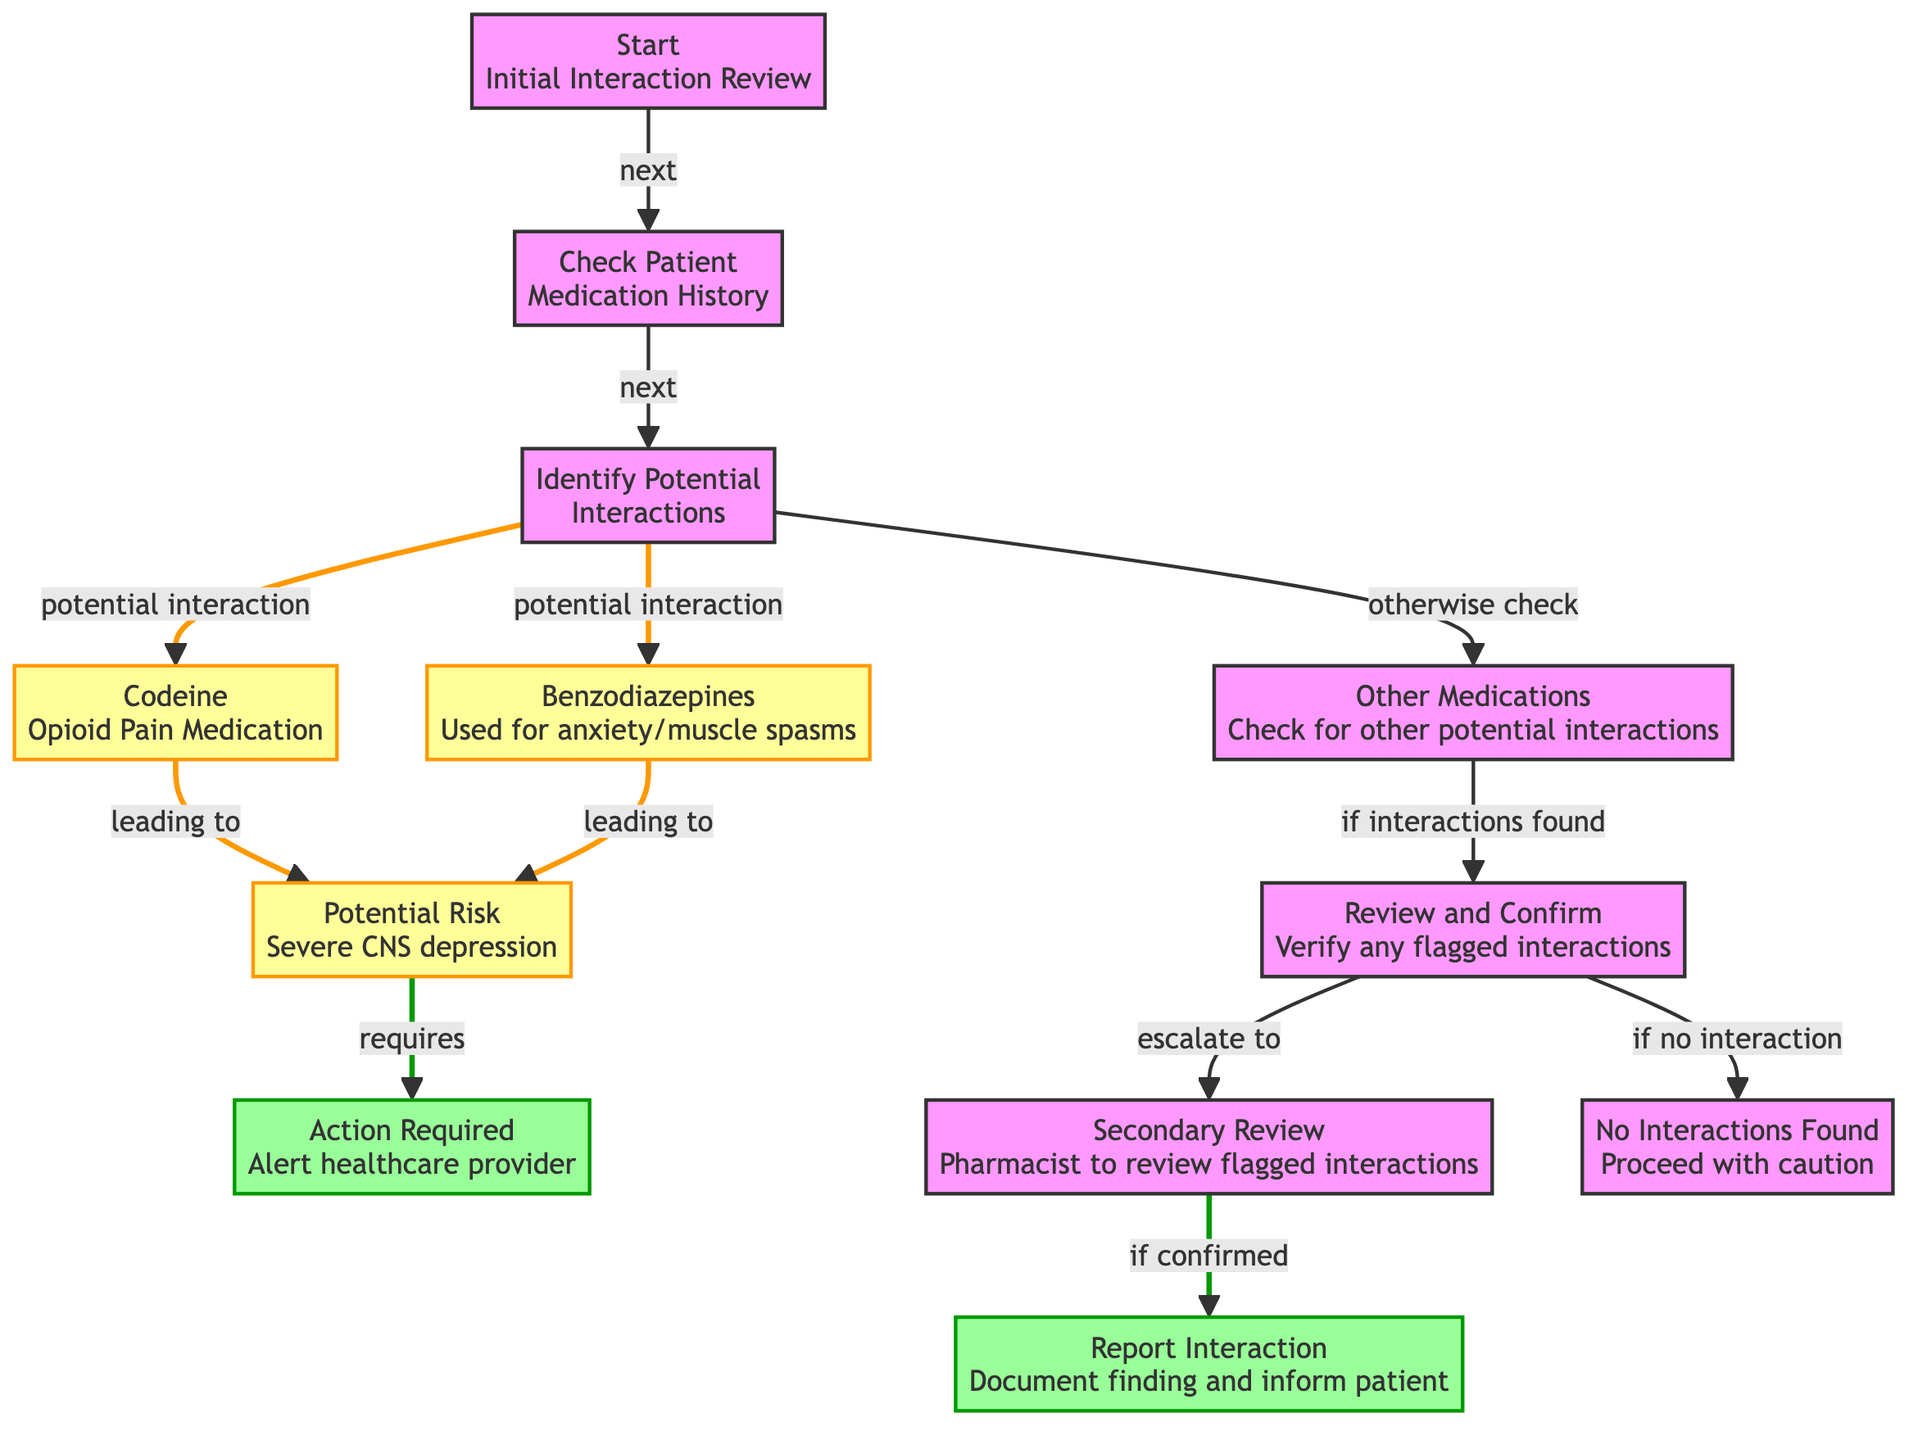What is the first step in the decision-making process? The first step is labeled as "Start: Initial Interaction Review." This is the starting point of the decision tree and initiates the review process.
Answer: Start: Initial Interaction Review How many potential interactions are identified in the diagram? There are two potential interactions identified: Codeine and Benzodiazepines. Each of these medications leads to a warning of potential risks.
Answer: 2 What action is required if severe CNS depression is identified? If severe CNS depression is identified, the action required is to "Alert healthcare provider." This shows the necessity of communicating the risk to healthcare professionals.
Answer: Alert healthcare provider What happens if no interactions are found during the review? If no interactions are found, the next step is to "Proceed with caution." This indicates a careful approach even when no issues are detected.
Answer: Proceed with caution What is the outcome of confirming a flagged interaction during the secondary review? If a flagged interaction is confirmed during the secondary review by the pharmacist, the next outcome is to "Report Interaction." This involves documentation and informing the patient.
Answer: Report Interaction Which node represents "Potential Risk"? The node representing "Potential Risk" is identified by the text "Potential Risk: Severe CNS depression." It is directly connected to the interactions identified.
Answer: Potential Risk: Severe CNS depression If a patient is on both Codeine and Benzodiazepines, what is the next step? If a patient is using both medications, the next step would lead to the "Potential Risk: Severe CNS depression," indicating a serious concern.
Answer: Potential Risk: Severe CNS depression What follows after verifying flagged interactions? After verifying flagged interactions, the next step is "Secondary Review." This indicates that a pharmacist must review the flagged interactions for further clarity.
Answer: Secondary Review What is indicated by the color of the nodes related to potential interactions? The nodes related to potential interactions are colored to signify a warning. This color coding highlights the urgency and seriousness of the situations presented.
Answer: Warning 